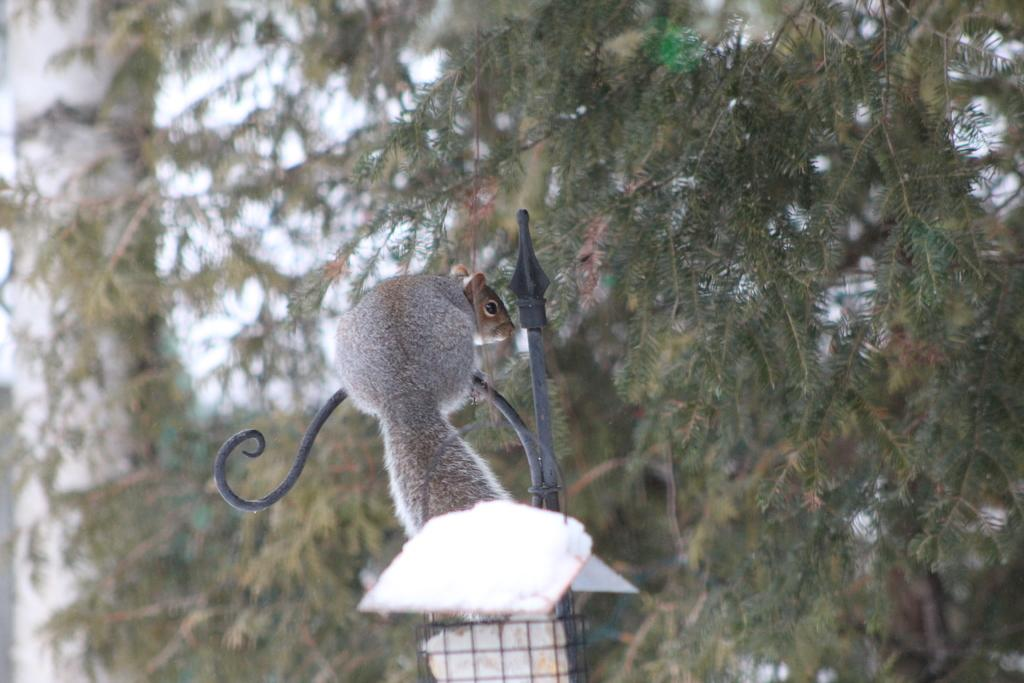What animal can be seen in the picture? There is a squirrel in the picture. What is the squirrel standing on? The squirrel is standing on an object. What type of natural environment is visible in the picture? There are many branches of a tree around the squirrel. What type of cactus can be seen in the picture? There is no cactus present in the picture; it features a squirrel standing on an object surrounded by tree branches. 